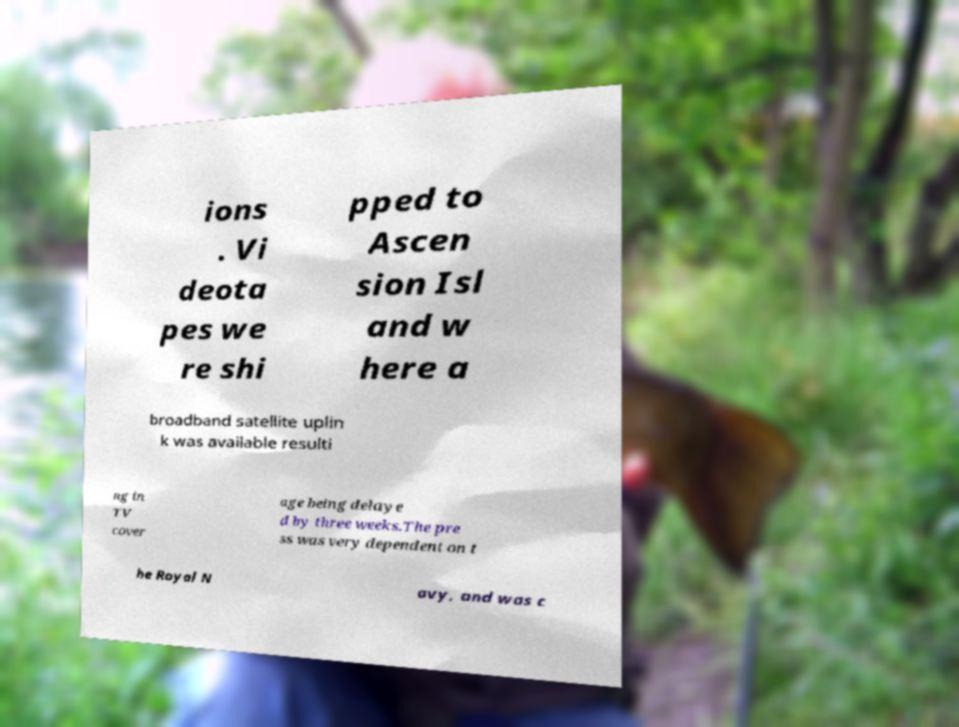There's text embedded in this image that I need extracted. Can you transcribe it verbatim? ions . Vi deota pes we re shi pped to Ascen sion Isl and w here a broadband satellite uplin k was available resulti ng in TV cover age being delaye d by three weeks.The pre ss was very dependent on t he Royal N avy, and was c 